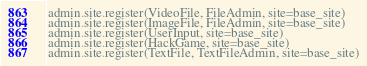<code> <loc_0><loc_0><loc_500><loc_500><_Python_>admin.site.register(VideoFile, FileAdmin, site=base_site)
admin.site.register(ImageFile, FileAdmin, site=base_site)
admin.site.register(UserInput, site=base_site)
admin.site.register(HackGame, site=base_site)
admin.site.register(TextFile, TextFileAdmin, site=base_site)
</code> 